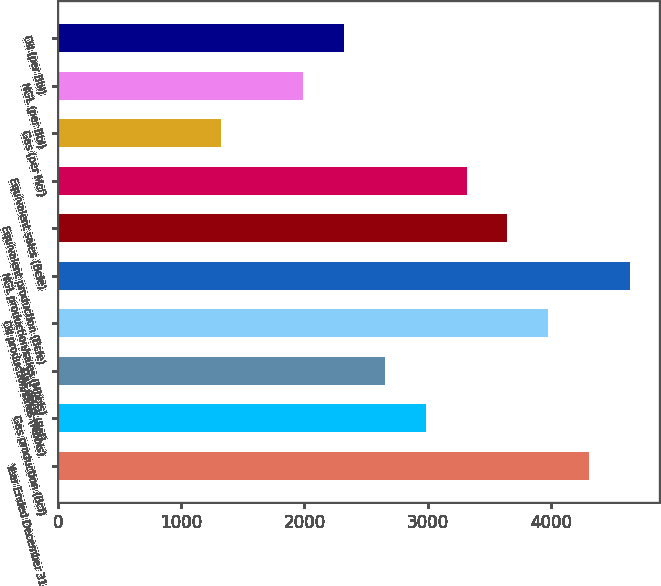Convert chart. <chart><loc_0><loc_0><loc_500><loc_500><bar_chart><fcel>Year Ended December 31<fcel>Gas production (Bcf)<fcel>Gas sales (Bcf)<fcel>Oil production/sales (Mbbls)<fcel>NGL production/sales (Mbbls)<fcel>Equivalent production (Bcfe)<fcel>Equivalent sales (Bcfe)<fcel>Gas (per Mcf)<fcel>NGL (per Bbl)<fcel>Oil (per Bbl)<nl><fcel>4310.51<fcel>2984.31<fcel>2652.76<fcel>3978.96<fcel>4642.06<fcel>3647.41<fcel>3315.86<fcel>1326.56<fcel>1989.66<fcel>2321.21<nl></chart> 